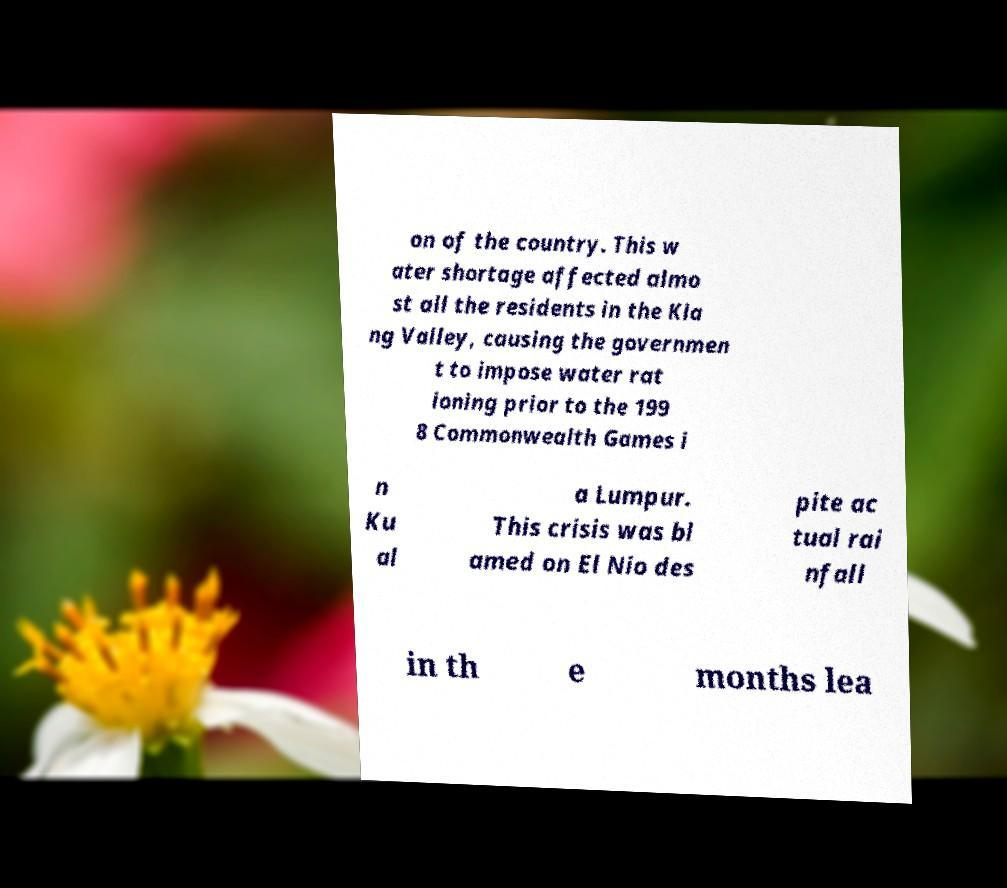I need the written content from this picture converted into text. Can you do that? on of the country. This w ater shortage affected almo st all the residents in the Kla ng Valley, causing the governmen t to impose water rat ioning prior to the 199 8 Commonwealth Games i n Ku al a Lumpur. This crisis was bl amed on El Nio des pite ac tual rai nfall in th e months lea 